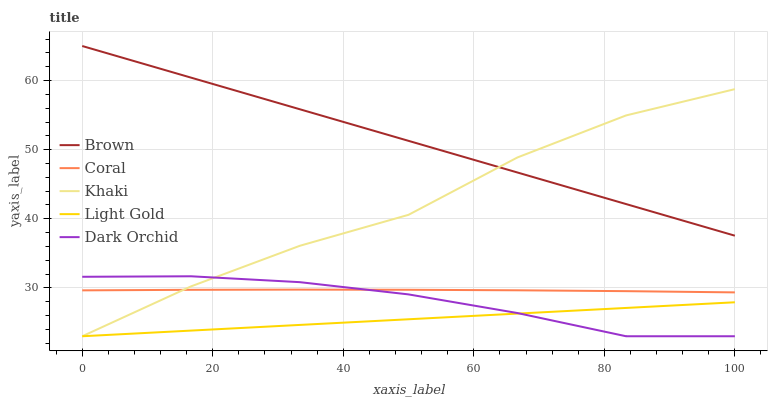Does Coral have the minimum area under the curve?
Answer yes or no. No. Does Coral have the maximum area under the curve?
Answer yes or no. No. Is Coral the smoothest?
Answer yes or no. No. Is Coral the roughest?
Answer yes or no. No. Does Coral have the lowest value?
Answer yes or no. No. Does Coral have the highest value?
Answer yes or no. No. Is Coral less than Brown?
Answer yes or no. Yes. Is Brown greater than Light Gold?
Answer yes or no. Yes. Does Coral intersect Brown?
Answer yes or no. No. 